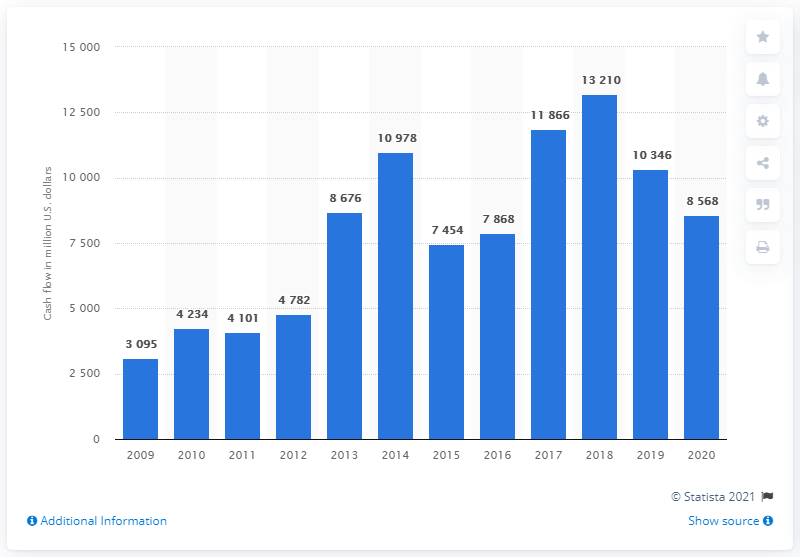Highlight a few significant elements in this photo. Glencore reported a cash flow of 8,568 in fiscal year 2020. 